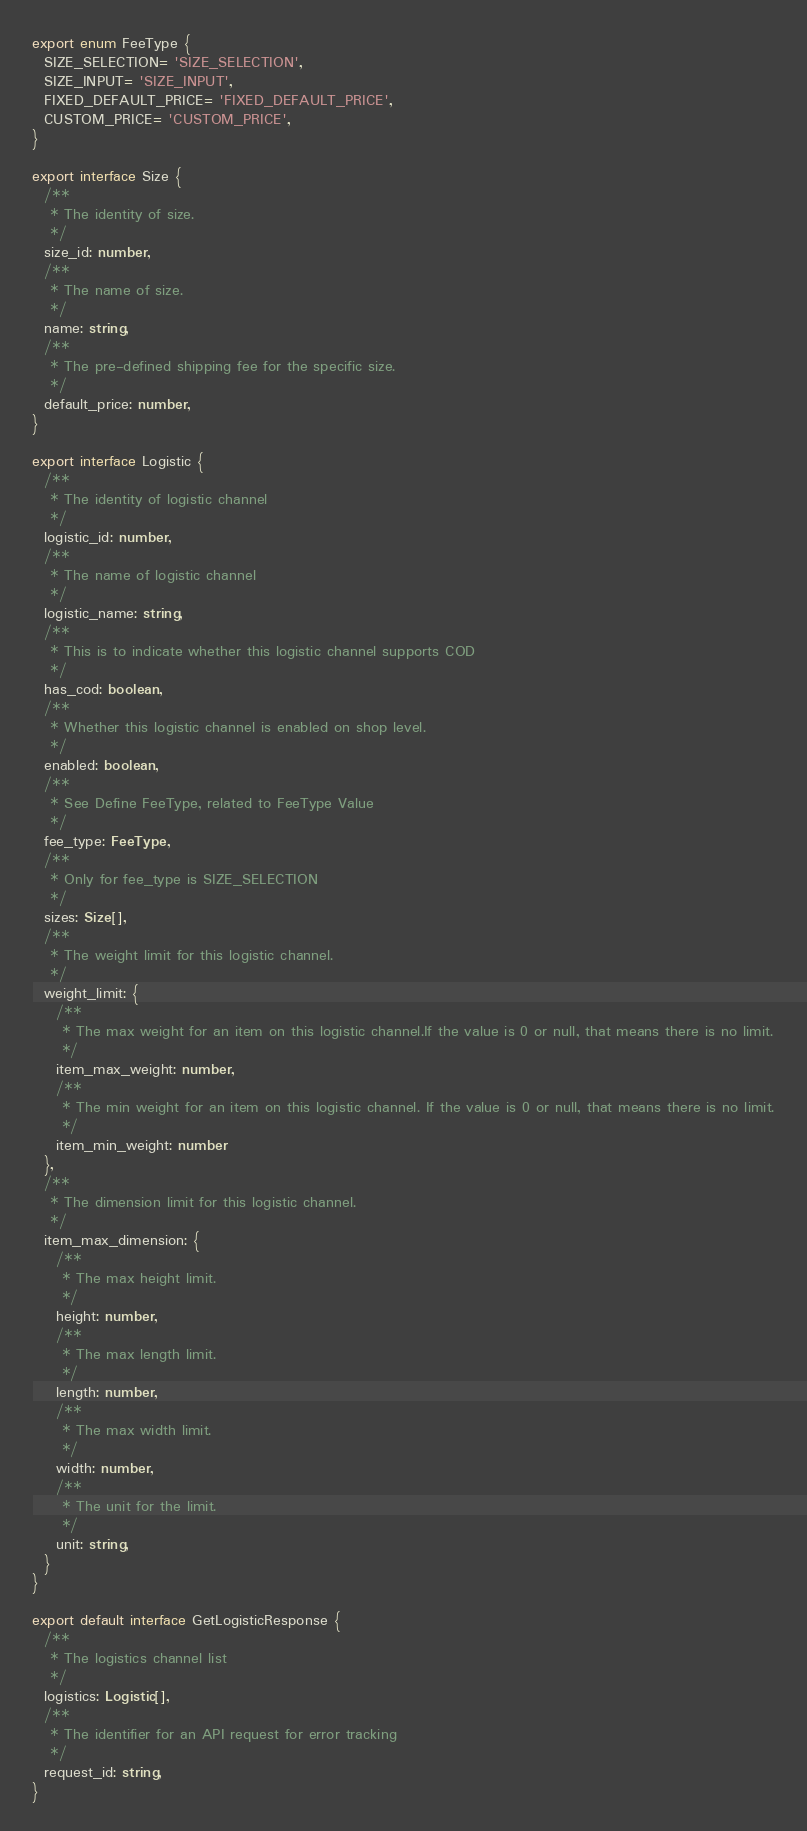<code> <loc_0><loc_0><loc_500><loc_500><_TypeScript_>
export enum FeeType {
  SIZE_SELECTION= 'SIZE_SELECTION',
  SIZE_INPUT= 'SIZE_INPUT',
  FIXED_DEFAULT_PRICE= 'FIXED_DEFAULT_PRICE',
  CUSTOM_PRICE= 'CUSTOM_PRICE',
}

export interface Size {
  /**
   * The identity of size.
   */
  size_id: number,
  /**
   * The name of size.
   */
  name: string,
  /**
   * The pre-defined shipping fee for the specific size.
   */
  default_price: number,
}

export interface Logistic {
  /**
   * The identity of logistic channel
   */
  logistic_id: number,
  /**
   * The name of logistic channel
   */
  logistic_name: string,
  /**
   * This is to indicate whether this logistic channel supports COD
   */
  has_cod: boolean,
  /**
   * Whether this logistic channel is enabled on shop level.
   */
  enabled: boolean,
  /**
   * See Define FeeType, related to FeeType Value
   */
  fee_type: FeeType,
  /**
   * Only for fee_type is SIZE_SELECTION
   */
  sizes: Size[],
  /**
   * The weight limit for this logistic channel.
   */
  weight_limit: {
    /**
     * The max weight for an item on this logistic channel.If the value is 0 or null, that means there is no limit.
     */
    item_max_weight: number,
    /**
     * The min weight for an item on this logistic channel. If the value is 0 or null, that means there is no limit.
     */
    item_min_weight: number
  },
  /**
   * The dimension limit for this logistic channel.
   */
  item_max_dimension: {
    /**
     * The max height limit.
     */
    height: number,
    /**
     * The max length limit.
     */
    length: number,
    /**
     * The max width limit.
     */
    width: number,
    /**
     * The unit for the limit.
     */
    unit: string,
  }
}

export default interface GetLogisticResponse {
  /**
   * The logistics channel list
   */
  logistics: Logistic[],
  /**
   * The identifier for an API request for error tracking
   */
  request_id: string,
}</code> 